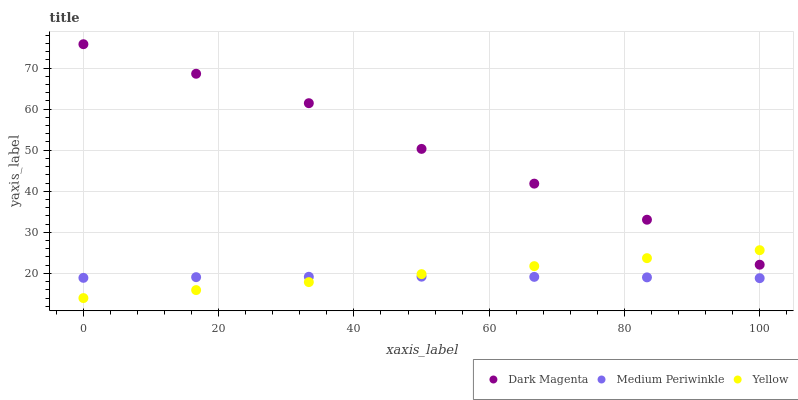Does Medium Periwinkle have the minimum area under the curve?
Answer yes or no. Yes. Does Dark Magenta have the maximum area under the curve?
Answer yes or no. Yes. Does Yellow have the minimum area under the curve?
Answer yes or no. No. Does Yellow have the maximum area under the curve?
Answer yes or no. No. Is Yellow the smoothest?
Answer yes or no. Yes. Is Dark Magenta the roughest?
Answer yes or no. Yes. Is Dark Magenta the smoothest?
Answer yes or no. No. Is Yellow the roughest?
Answer yes or no. No. Does Yellow have the lowest value?
Answer yes or no. Yes. Does Dark Magenta have the lowest value?
Answer yes or no. No. Does Dark Magenta have the highest value?
Answer yes or no. Yes. Does Yellow have the highest value?
Answer yes or no. No. Is Medium Periwinkle less than Dark Magenta?
Answer yes or no. Yes. Is Dark Magenta greater than Medium Periwinkle?
Answer yes or no. Yes. Does Dark Magenta intersect Yellow?
Answer yes or no. Yes. Is Dark Magenta less than Yellow?
Answer yes or no. No. Is Dark Magenta greater than Yellow?
Answer yes or no. No. Does Medium Periwinkle intersect Dark Magenta?
Answer yes or no. No. 